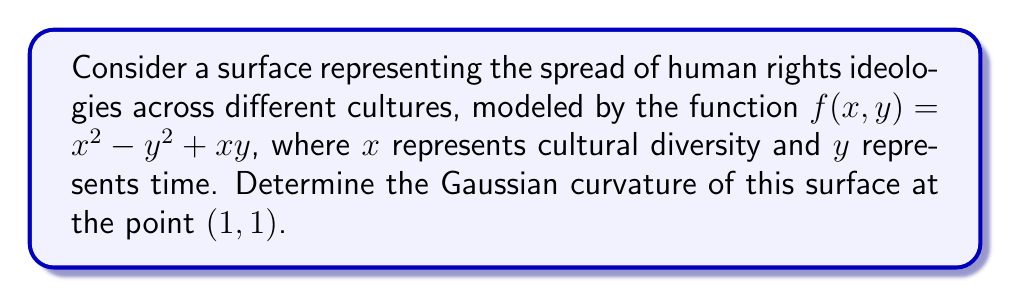Could you help me with this problem? To find the Gaussian curvature, we need to calculate the first and second fundamental forms of the surface.

Step 1: Calculate the partial derivatives
$$f_x = 2x + y$$
$$f_y = -2y + x$$
$$f_{xx} = 2$$
$$f_{yy} = -2$$
$$f_{xy} = f_{yx} = 1$$

Step 2: Calculate the components of the first fundamental form
$$E = 1 + f_x^2 = 1 + (2x + y)^2$$
$$F = f_x f_y = (2x + y)(-2y + x)$$
$$G = 1 + f_y^2 = 1 + (-2y + x)^2$$

Step 3: Calculate the components of the second fundamental form
$$L = \frac{f_{xx}}{\sqrt{1 + f_x^2 + f_y^2}} = \frac{2}{\sqrt{1 + (2x + y)^2 + (-2y + x)^2}}$$
$$M = \frac{f_{xy}}{\sqrt{1 + f_x^2 + f_y^2}} = \frac{1}{\sqrt{1 + (2x + y)^2 + (-2y + x)^2}}$$
$$N = \frac{f_{yy}}{\sqrt{1 + f_x^2 + f_y^2}} = \frac{-2}{\sqrt{1 + (2x + y)^2 + (-2y + x)^2}}$$

Step 4: Calculate the Gaussian curvature
The Gaussian curvature K is given by:
$$K = \frac{LN - M^2}{EG - F^2}$$

Step 5: Evaluate at the point (1, 1)
At (1, 1):
$$E = 1 + (2(1) + 1)^2 = 10$$
$$F = (2(1) + 1)(-2(1) + 1) = -3$$
$$G = 1 + (-2(1) + 1)^2 = 2$$
$$L = \frac{2}{\sqrt{1 + (2(1) + 1)^2 + (-2(1) + 1)^2}} = \frac{2}{\sqrt{14}}$$
$$M = \frac{1}{\sqrt{14}}$$
$$N = \frac{-2}{\sqrt{14}}$$

Substituting these values into the Gaussian curvature formula:
$$K = \frac{(\frac{2}{\sqrt{14}})(\frac{-2}{\sqrt{14}}) - (\frac{1}{\sqrt{14}})^2}{(10)(2) - (-3)^2} = \frac{-4/14 - 1/14}{20 - 9} = \frac{-5/14}{11} = -\frac{5}{154}$$
Answer: $-\frac{5}{154}$ 